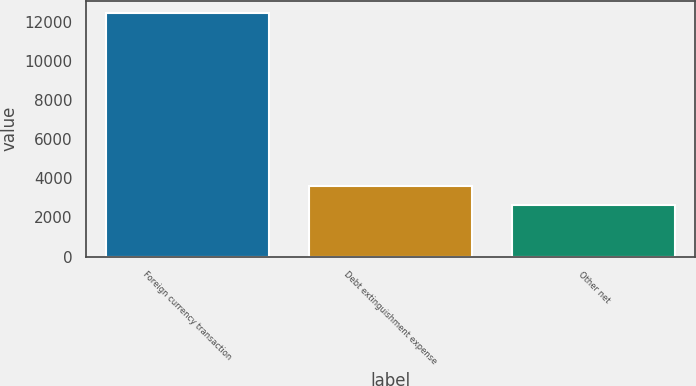Convert chart. <chart><loc_0><loc_0><loc_500><loc_500><bar_chart><fcel>Foreign currency transaction<fcel>Debt extinguishment expense<fcel>Other net<nl><fcel>12477<fcel>3617.4<fcel>2633<nl></chart> 